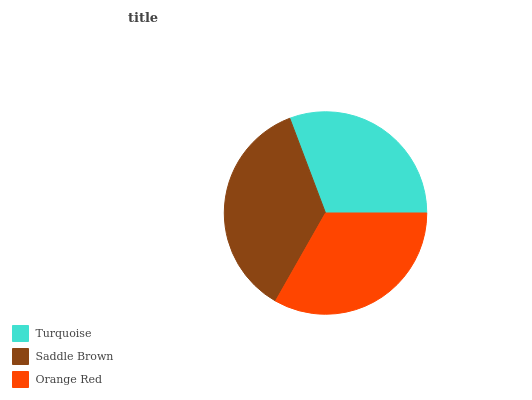Is Turquoise the minimum?
Answer yes or no. Yes. Is Saddle Brown the maximum?
Answer yes or no. Yes. Is Orange Red the minimum?
Answer yes or no. No. Is Orange Red the maximum?
Answer yes or no. No. Is Saddle Brown greater than Orange Red?
Answer yes or no. Yes. Is Orange Red less than Saddle Brown?
Answer yes or no. Yes. Is Orange Red greater than Saddle Brown?
Answer yes or no. No. Is Saddle Brown less than Orange Red?
Answer yes or no. No. Is Orange Red the high median?
Answer yes or no. Yes. Is Orange Red the low median?
Answer yes or no. Yes. Is Saddle Brown the high median?
Answer yes or no. No. Is Saddle Brown the low median?
Answer yes or no. No. 